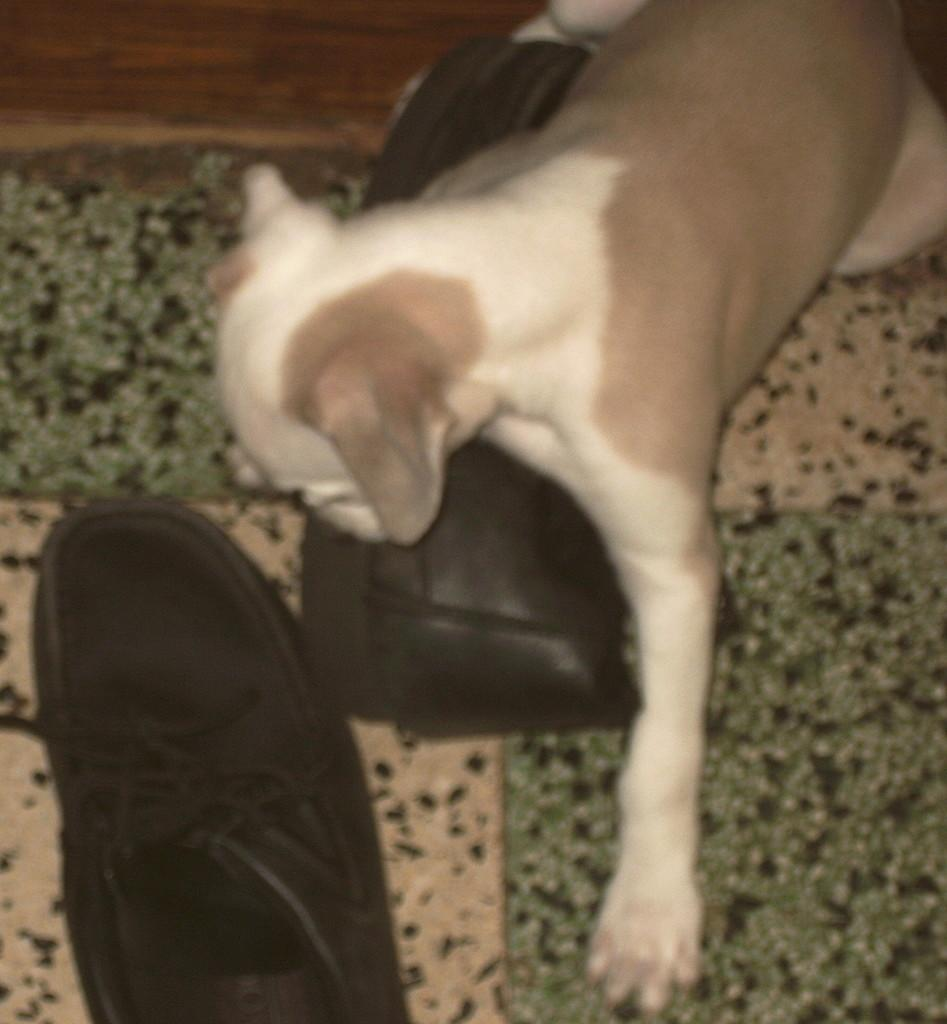Where was the image taken? The image was taken indoors. What can be seen under the subjects in the image? There is a floor visible in the image. What objects are in the middle of the image? There are two shoes in the middle of the image. What is the dog doing in the image? A dog is playing with a shoe in the image. What is the income of the dog in the image? There is no information about the dog's income in the image. 